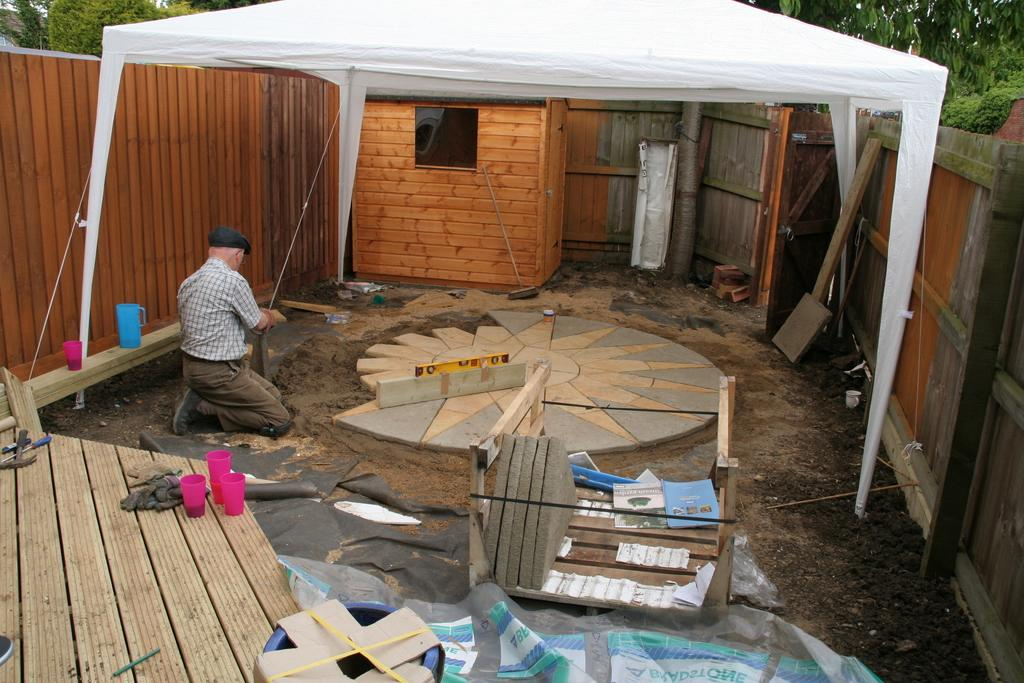Who or what is present in the image? There is a person in the image. What type of structure can be seen in the image? There is a house in the image. What architectural feature is visible in the image? There is a wall in the image. What object is used for holding liquids in the image? There is a jug in the image. What objects are used for drinking in the image? There are glasses in the image. What items are used for various tasks in the image? There are tools in the image. What material is present in the image? There is wood in the image. What is hanging in the image? There is a banner in the image. What type of natural scenery is visible in the background of the image? There are trees in the background of the image. How many dimes are scattered on the ground in the image? There are no dimes present in the image. What type of beetle can be seen crawling on the person's shoulder in the image? There are no beetles present in the image. 